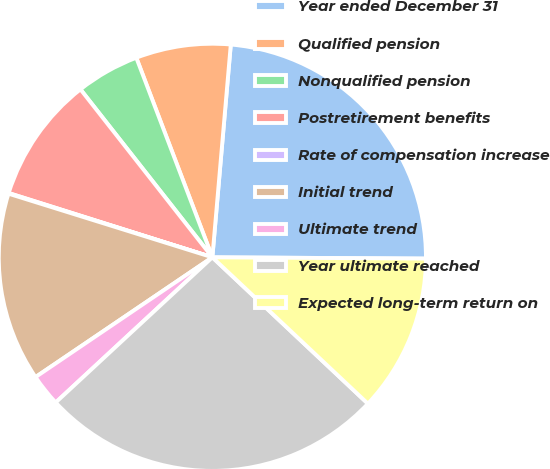Convert chart. <chart><loc_0><loc_0><loc_500><loc_500><pie_chart><fcel>Year ended December 31<fcel>Qualified pension<fcel>Nonqualified pension<fcel>Postretirement benefits<fcel>Rate of compensation increase<fcel>Initial trend<fcel>Ultimate trend<fcel>Year ultimate reached<fcel>Expected long-term return on<nl><fcel>23.72%<fcel>7.17%<fcel>4.8%<fcel>9.54%<fcel>0.05%<fcel>14.29%<fcel>2.42%<fcel>26.09%<fcel>11.92%<nl></chart> 